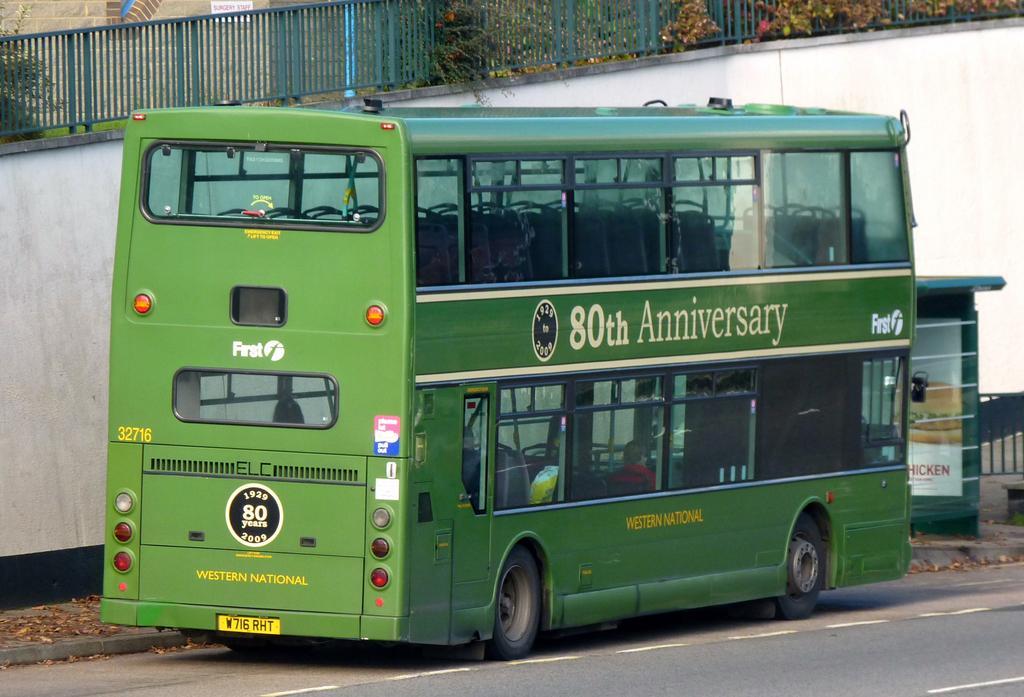Can you describe this image briefly? In this image I can see the road, a bus which is green in color on the road. I can see a person wearing red color dress is sitting in the bus and few leaves on the side walk. In the background I can see the white colored wall, the railing, few trees and the building. 